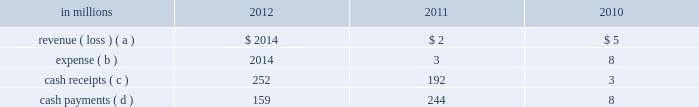Determined that it was the primary beneficiary of the 2001 financing entities and thus consolidated the entities effective march 16 , 2011 .
Effective april 30 , 2011 , international paper liquidated its interest in the 2001 financing entities .
Activity between the company and the 2002 financ- ing entities was as follows: .
( a ) the revenue is included in equity earnings ( loss ) , net of tax in the accompanying consolidated statement of operations .
( b ) the expense is included in interest expense , net in the accom- panying consolidated statement of operations .
( c ) the cash receipts are equity distributions from the 2002 financ- ing entities to international paper and cash receipts from the maturity of the 2002 monetized notes .
( d ) the cash payments include both interest and principal on the associated debt obligations .
On may 31 , 2011 , the third-party equity holder of the 2002 financing entities retired its class a interest in the entities for $ 51 million .
As a result of the retire- ment , effective may 31 , 2011 , international paper owned 100% ( 100 % ) of the 2002 financing entities .
Based on an analysis performed by the company after the retirement , under guidance that considers the poten- tial magnitude of the variability in the structure and which party has controlling financial interest , international paper determined that it was the pri- mary beneficiary of the 2002 financing entities and thus consolidated the entities effective may 31 , 2011 .
During the year ended december 31 , 2011 approx- imately $ 191 million of the 2002 monetized notes matured .
Outstanding debt related to these entities of $ 158 million is included in floating rate notes due 2011 2013 2017 in the summary of long-term debt in note 12 at december 31 , 2011 .
As of may 31 , 2012 , this debt had been repaid .
During the year ended december 31 , 2012 , $ 252 mil- lion of the 2002 monetized notes matured .
As of result of these maturities , accounts and notes receivable decreased $ 252 million and notes payable and current maturities of long-term debt decreased $ 158 million .
Deferred tax liabilities associated with the 2002 forestland installment sales decreased $ 67 million .
Effective june 1 , 2012 , international paper liquidated its interest in the 2002 financing entities .
The use of the above entities facilitated the mone- tization of the credit enhanced timber and mone- tized notes in a cost effective manner by increasing the borrowing capacity and lowering the interest rate while continuing to preserve the tax deferral that resulted from the forestlands installment sales and the offset accounting treatment described above .
In connection with the acquisition of temple-inland in february 2012 , two special purpose entities became wholly-owned subsidiaries of international paper .
In october 2007 , temple-inland sold 1.55 million acres of timberlands for $ 2.38 billion .
The total con- sideration consisted almost entirely of notes due in 2027 issued by the buyer of the timberlands , which temple-inland contributed to two wholly-owned , bankruptcy-remote special purpose entities .
The notes are shown in financial assets of special pur- pose entities in the accompanying consolidated balance sheet and are supported by $ 2.38 billion of irrevocable letters of credit issued by three banks , which are required to maintain minimum credit rat- ings on their long-term debt .
In the third quarter of 2012 , international paper completed is preliminary analysis of the acquisition date fair value of the notes and determined it to be $ 2.09 billion .
As a result of this analysis , financial assets of special purposed entities decreased by $ 292 million and goodwill increased by the same amount .
As of december 31 , 2012 , the fair value of the notes was $ 2.21 billion .
In december 2007 , temple-inland 2019s two wholly- owned special purpose entities borrowed $ 2.14 bil- lion shown in nonrecourse financial liabilities of special purpose entities in the accompanying con- solidated balance sheet .
The loans are repayable in 2027 and are secured only by the $ 2.38 billion of notes and the irrevocable letters of credit securing the notes and are nonrecourse to the company .
The loan agreements provide that if a credit rating of any of the banks issuing the letters of credit is down- graded below the specified threshold , the letters of credit issued by that bank must be replaced within 30 days with letters of credit from another qualifying financial institution .
In the third quarter of 2012 , international paper completed its preliminary analy- sis of the acquisition date fair value of the borrow- ings and determined it to be $ 2.03 billion .
As a result of this analysis , nonrecourse financial liabilities of special purpose entities decreased by $ 110 million and goodwill decreased by the same amount .
As of december 31 , 2012 , the fair value of this debt was $ 2.12 billion .
The buyer of the temple-inland timberland issued the $ 2.38 billion in notes from its wholly-owned , bankruptcy-remote special purpose entities .
The buyer 2019s special purpose entities held the timberlands from the transaction date until november 2008 , at which time the timberlands were transferred out of the buyer 2019s special purpose entities .
Due to the transfer of the timberlands , temple-inland evaluated the buyer 2019s special purpose entities and determined that they were variable interest entities and that temple-inland was the primary beneficiary .
As a result , in 2008 , temple-inland .
For the three years of 2010 , 2011 and 2012 what was the net cash impact from the 2002 financing entities? 
Rationale: summing the inflows and outflows gives us a look a the contribution over the 3 years of the financing entities relationship and benefit or drag on the company .
Computations: (((252 + 192) + 3) - ((159 + 244) + 8))
Answer: 36.0. Determined that it was the primary beneficiary of the 2001 financing entities and thus consolidated the entities effective march 16 , 2011 .
Effective april 30 , 2011 , international paper liquidated its interest in the 2001 financing entities .
Activity between the company and the 2002 financ- ing entities was as follows: .
( a ) the revenue is included in equity earnings ( loss ) , net of tax in the accompanying consolidated statement of operations .
( b ) the expense is included in interest expense , net in the accom- panying consolidated statement of operations .
( c ) the cash receipts are equity distributions from the 2002 financ- ing entities to international paper and cash receipts from the maturity of the 2002 monetized notes .
( d ) the cash payments include both interest and principal on the associated debt obligations .
On may 31 , 2011 , the third-party equity holder of the 2002 financing entities retired its class a interest in the entities for $ 51 million .
As a result of the retire- ment , effective may 31 , 2011 , international paper owned 100% ( 100 % ) of the 2002 financing entities .
Based on an analysis performed by the company after the retirement , under guidance that considers the poten- tial magnitude of the variability in the structure and which party has controlling financial interest , international paper determined that it was the pri- mary beneficiary of the 2002 financing entities and thus consolidated the entities effective may 31 , 2011 .
During the year ended december 31 , 2011 approx- imately $ 191 million of the 2002 monetized notes matured .
Outstanding debt related to these entities of $ 158 million is included in floating rate notes due 2011 2013 2017 in the summary of long-term debt in note 12 at december 31 , 2011 .
As of may 31 , 2012 , this debt had been repaid .
During the year ended december 31 , 2012 , $ 252 mil- lion of the 2002 monetized notes matured .
As of result of these maturities , accounts and notes receivable decreased $ 252 million and notes payable and current maturities of long-term debt decreased $ 158 million .
Deferred tax liabilities associated with the 2002 forestland installment sales decreased $ 67 million .
Effective june 1 , 2012 , international paper liquidated its interest in the 2002 financing entities .
The use of the above entities facilitated the mone- tization of the credit enhanced timber and mone- tized notes in a cost effective manner by increasing the borrowing capacity and lowering the interest rate while continuing to preserve the tax deferral that resulted from the forestlands installment sales and the offset accounting treatment described above .
In connection with the acquisition of temple-inland in february 2012 , two special purpose entities became wholly-owned subsidiaries of international paper .
In october 2007 , temple-inland sold 1.55 million acres of timberlands for $ 2.38 billion .
The total con- sideration consisted almost entirely of notes due in 2027 issued by the buyer of the timberlands , which temple-inland contributed to two wholly-owned , bankruptcy-remote special purpose entities .
The notes are shown in financial assets of special pur- pose entities in the accompanying consolidated balance sheet and are supported by $ 2.38 billion of irrevocable letters of credit issued by three banks , which are required to maintain minimum credit rat- ings on their long-term debt .
In the third quarter of 2012 , international paper completed is preliminary analysis of the acquisition date fair value of the notes and determined it to be $ 2.09 billion .
As a result of this analysis , financial assets of special purposed entities decreased by $ 292 million and goodwill increased by the same amount .
As of december 31 , 2012 , the fair value of the notes was $ 2.21 billion .
In december 2007 , temple-inland 2019s two wholly- owned special purpose entities borrowed $ 2.14 bil- lion shown in nonrecourse financial liabilities of special purpose entities in the accompanying con- solidated balance sheet .
The loans are repayable in 2027 and are secured only by the $ 2.38 billion of notes and the irrevocable letters of credit securing the notes and are nonrecourse to the company .
The loan agreements provide that if a credit rating of any of the banks issuing the letters of credit is down- graded below the specified threshold , the letters of credit issued by that bank must be replaced within 30 days with letters of credit from another qualifying financial institution .
In the third quarter of 2012 , international paper completed its preliminary analy- sis of the acquisition date fair value of the borrow- ings and determined it to be $ 2.03 billion .
As a result of this analysis , nonrecourse financial liabilities of special purpose entities decreased by $ 110 million and goodwill decreased by the same amount .
As of december 31 , 2012 , the fair value of this debt was $ 2.12 billion .
The buyer of the temple-inland timberland issued the $ 2.38 billion in notes from its wholly-owned , bankruptcy-remote special purpose entities .
The buyer 2019s special purpose entities held the timberlands from the transaction date until november 2008 , at which time the timberlands were transferred out of the buyer 2019s special purpose entities .
Due to the transfer of the timberlands , temple-inland evaluated the buyer 2019s special purpose entities and determined that they were variable interest entities and that temple-inland was the primary beneficiary .
As a result , in 2008 , temple-inland .
Based on the review of the activity between the company and the 2002 financ- ing entities what was the ratio of the revenue to the expense in 2010? 
Computations: (5 / 8)
Answer: 0.625. 